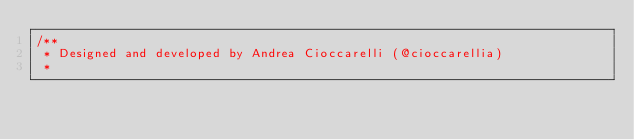Convert code to text. <code><loc_0><loc_0><loc_500><loc_500><_Kotlin_>/**
 * Designed and developed by Andrea Cioccarelli (@cioccarellia)
 *</code> 